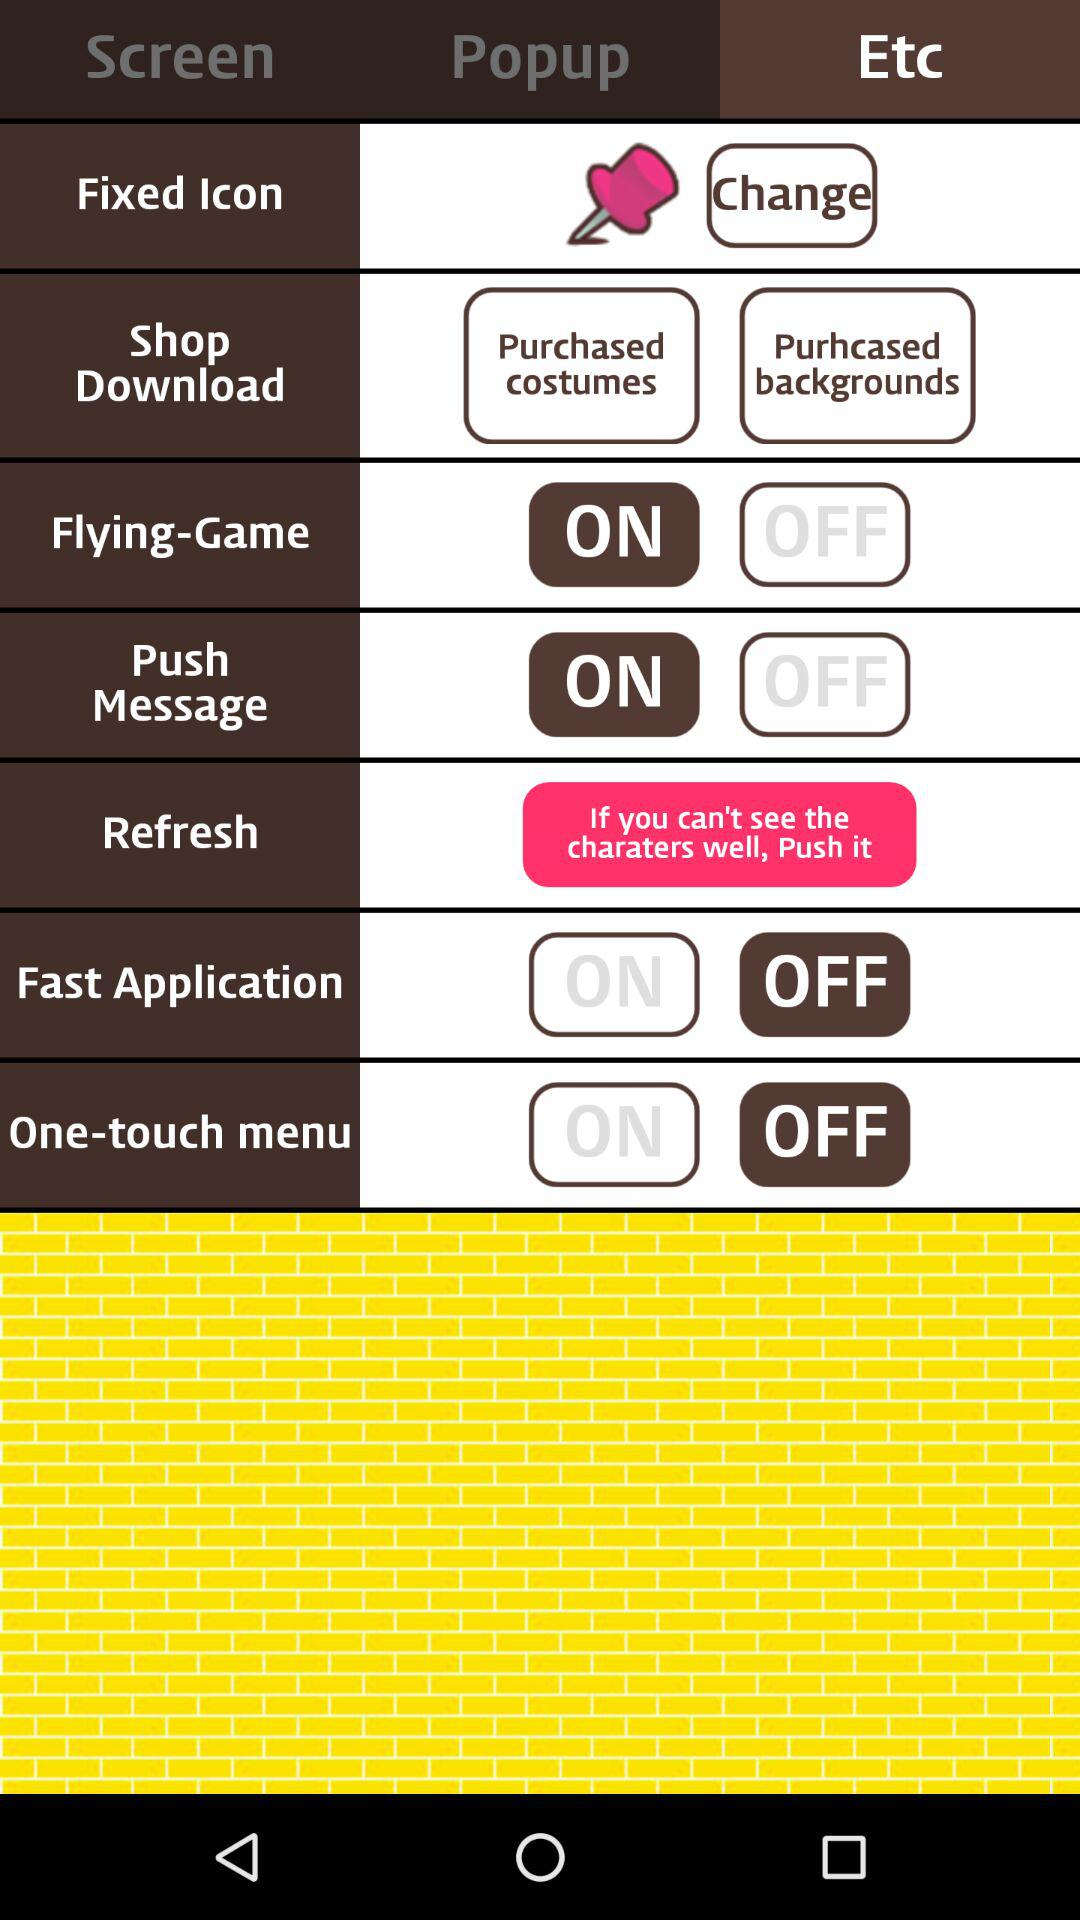Which tab is selected? The selected tab is "Etc". 